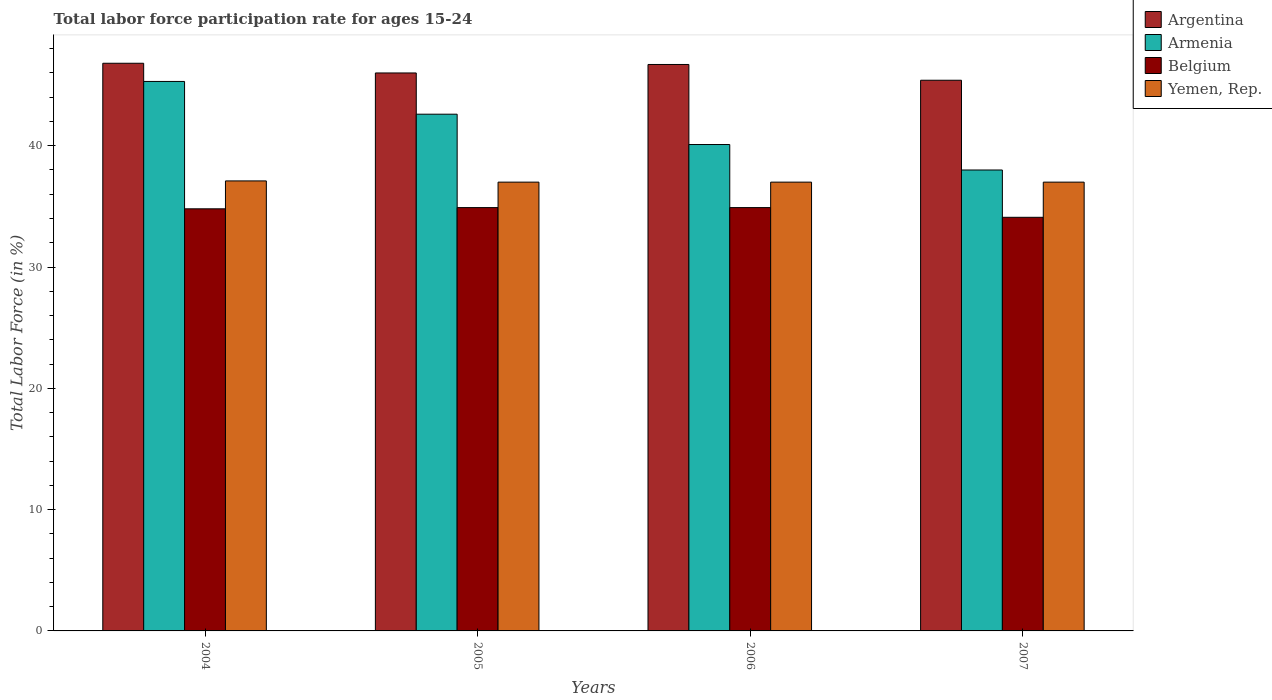How many groups of bars are there?
Your answer should be compact. 4. Are the number of bars per tick equal to the number of legend labels?
Provide a short and direct response. Yes. Are the number of bars on each tick of the X-axis equal?
Offer a terse response. Yes. How many bars are there on the 3rd tick from the right?
Provide a succinct answer. 4. What is the labor force participation rate in Argentina in 2007?
Offer a terse response. 45.4. Across all years, what is the maximum labor force participation rate in Belgium?
Provide a short and direct response. 34.9. Across all years, what is the minimum labor force participation rate in Argentina?
Provide a succinct answer. 45.4. In which year was the labor force participation rate in Armenia maximum?
Make the answer very short. 2004. In which year was the labor force participation rate in Belgium minimum?
Provide a short and direct response. 2007. What is the total labor force participation rate in Argentina in the graph?
Keep it short and to the point. 184.9. What is the difference between the labor force participation rate in Armenia in 2006 and that in 2007?
Provide a succinct answer. 2.1. What is the difference between the labor force participation rate in Belgium in 2005 and the labor force participation rate in Argentina in 2006?
Your response must be concise. -11.8. What is the average labor force participation rate in Yemen, Rep. per year?
Your response must be concise. 37.02. What is the ratio of the labor force participation rate in Yemen, Rep. in 2004 to that in 2005?
Provide a succinct answer. 1. Is the labor force participation rate in Belgium in 2004 less than that in 2006?
Your response must be concise. Yes. What is the difference between the highest and the second highest labor force participation rate in Armenia?
Offer a very short reply. 2.7. What is the difference between the highest and the lowest labor force participation rate in Belgium?
Offer a terse response. 0.8. In how many years, is the labor force participation rate in Yemen, Rep. greater than the average labor force participation rate in Yemen, Rep. taken over all years?
Provide a succinct answer. 1. Is it the case that in every year, the sum of the labor force participation rate in Argentina and labor force participation rate in Armenia is greater than the sum of labor force participation rate in Belgium and labor force participation rate in Yemen, Rep.?
Give a very brief answer. Yes. What does the 2nd bar from the left in 2004 represents?
Your answer should be very brief. Armenia. What does the 3rd bar from the right in 2006 represents?
Provide a short and direct response. Armenia. How many bars are there?
Ensure brevity in your answer.  16. What is the difference between two consecutive major ticks on the Y-axis?
Your response must be concise. 10. Are the values on the major ticks of Y-axis written in scientific E-notation?
Provide a short and direct response. No. Does the graph contain any zero values?
Ensure brevity in your answer.  No. Does the graph contain grids?
Your response must be concise. No. Where does the legend appear in the graph?
Ensure brevity in your answer.  Top right. How many legend labels are there?
Provide a succinct answer. 4. How are the legend labels stacked?
Provide a short and direct response. Vertical. What is the title of the graph?
Provide a succinct answer. Total labor force participation rate for ages 15-24. What is the label or title of the Y-axis?
Keep it short and to the point. Total Labor Force (in %). What is the Total Labor Force (in %) in Argentina in 2004?
Offer a terse response. 46.8. What is the Total Labor Force (in %) in Armenia in 2004?
Offer a terse response. 45.3. What is the Total Labor Force (in %) in Belgium in 2004?
Ensure brevity in your answer.  34.8. What is the Total Labor Force (in %) in Yemen, Rep. in 2004?
Your answer should be very brief. 37.1. What is the Total Labor Force (in %) of Argentina in 2005?
Give a very brief answer. 46. What is the Total Labor Force (in %) in Armenia in 2005?
Your answer should be compact. 42.6. What is the Total Labor Force (in %) of Belgium in 2005?
Ensure brevity in your answer.  34.9. What is the Total Labor Force (in %) in Yemen, Rep. in 2005?
Provide a succinct answer. 37. What is the Total Labor Force (in %) of Argentina in 2006?
Your answer should be very brief. 46.7. What is the Total Labor Force (in %) of Armenia in 2006?
Ensure brevity in your answer.  40.1. What is the Total Labor Force (in %) of Belgium in 2006?
Offer a very short reply. 34.9. What is the Total Labor Force (in %) of Yemen, Rep. in 2006?
Offer a terse response. 37. What is the Total Labor Force (in %) of Argentina in 2007?
Offer a very short reply. 45.4. What is the Total Labor Force (in %) of Belgium in 2007?
Offer a terse response. 34.1. What is the Total Labor Force (in %) in Yemen, Rep. in 2007?
Your answer should be compact. 37. Across all years, what is the maximum Total Labor Force (in %) in Argentina?
Ensure brevity in your answer.  46.8. Across all years, what is the maximum Total Labor Force (in %) in Armenia?
Your response must be concise. 45.3. Across all years, what is the maximum Total Labor Force (in %) in Belgium?
Provide a short and direct response. 34.9. Across all years, what is the maximum Total Labor Force (in %) of Yemen, Rep.?
Provide a succinct answer. 37.1. Across all years, what is the minimum Total Labor Force (in %) of Argentina?
Ensure brevity in your answer.  45.4. Across all years, what is the minimum Total Labor Force (in %) in Belgium?
Offer a terse response. 34.1. What is the total Total Labor Force (in %) in Argentina in the graph?
Your answer should be very brief. 184.9. What is the total Total Labor Force (in %) of Armenia in the graph?
Your answer should be compact. 166. What is the total Total Labor Force (in %) of Belgium in the graph?
Provide a succinct answer. 138.7. What is the total Total Labor Force (in %) in Yemen, Rep. in the graph?
Provide a short and direct response. 148.1. What is the difference between the Total Labor Force (in %) in Argentina in 2004 and that in 2005?
Provide a short and direct response. 0.8. What is the difference between the Total Labor Force (in %) in Armenia in 2004 and that in 2005?
Keep it short and to the point. 2.7. What is the difference between the Total Labor Force (in %) in Belgium in 2004 and that in 2005?
Keep it short and to the point. -0.1. What is the difference between the Total Labor Force (in %) in Argentina in 2004 and that in 2006?
Offer a terse response. 0.1. What is the difference between the Total Labor Force (in %) in Yemen, Rep. in 2004 and that in 2006?
Provide a succinct answer. 0.1. What is the difference between the Total Labor Force (in %) of Argentina in 2004 and that in 2007?
Provide a succinct answer. 1.4. What is the difference between the Total Labor Force (in %) in Armenia in 2004 and that in 2007?
Offer a terse response. 7.3. What is the difference between the Total Labor Force (in %) of Armenia in 2005 and that in 2006?
Offer a very short reply. 2.5. What is the difference between the Total Labor Force (in %) in Armenia in 2005 and that in 2007?
Ensure brevity in your answer.  4.6. What is the difference between the Total Labor Force (in %) of Belgium in 2005 and that in 2007?
Make the answer very short. 0.8. What is the difference between the Total Labor Force (in %) of Yemen, Rep. in 2005 and that in 2007?
Your response must be concise. 0. What is the difference between the Total Labor Force (in %) of Argentina in 2006 and that in 2007?
Offer a very short reply. 1.3. What is the difference between the Total Labor Force (in %) of Armenia in 2006 and that in 2007?
Your answer should be compact. 2.1. What is the difference between the Total Labor Force (in %) of Belgium in 2006 and that in 2007?
Provide a succinct answer. 0.8. What is the difference between the Total Labor Force (in %) in Armenia in 2004 and the Total Labor Force (in %) in Belgium in 2005?
Your response must be concise. 10.4. What is the difference between the Total Labor Force (in %) in Armenia in 2004 and the Total Labor Force (in %) in Yemen, Rep. in 2005?
Keep it short and to the point. 8.3. What is the difference between the Total Labor Force (in %) in Belgium in 2004 and the Total Labor Force (in %) in Yemen, Rep. in 2005?
Your answer should be compact. -2.2. What is the difference between the Total Labor Force (in %) in Argentina in 2004 and the Total Labor Force (in %) in Armenia in 2006?
Your response must be concise. 6.7. What is the difference between the Total Labor Force (in %) of Argentina in 2004 and the Total Labor Force (in %) of Armenia in 2007?
Give a very brief answer. 8.8. What is the difference between the Total Labor Force (in %) in Argentina in 2004 and the Total Labor Force (in %) in Belgium in 2007?
Provide a succinct answer. 12.7. What is the difference between the Total Labor Force (in %) in Argentina in 2004 and the Total Labor Force (in %) in Yemen, Rep. in 2007?
Your answer should be compact. 9.8. What is the difference between the Total Labor Force (in %) of Armenia in 2004 and the Total Labor Force (in %) of Belgium in 2007?
Your answer should be compact. 11.2. What is the difference between the Total Labor Force (in %) in Armenia in 2004 and the Total Labor Force (in %) in Yemen, Rep. in 2007?
Keep it short and to the point. 8.3. What is the difference between the Total Labor Force (in %) in Belgium in 2004 and the Total Labor Force (in %) in Yemen, Rep. in 2007?
Your answer should be very brief. -2.2. What is the difference between the Total Labor Force (in %) in Argentina in 2005 and the Total Labor Force (in %) in Armenia in 2006?
Offer a very short reply. 5.9. What is the difference between the Total Labor Force (in %) in Argentina in 2005 and the Total Labor Force (in %) in Belgium in 2006?
Make the answer very short. 11.1. What is the difference between the Total Labor Force (in %) in Armenia in 2005 and the Total Labor Force (in %) in Belgium in 2006?
Your answer should be very brief. 7.7. What is the difference between the Total Labor Force (in %) in Argentina in 2005 and the Total Labor Force (in %) in Belgium in 2007?
Offer a very short reply. 11.9. What is the difference between the Total Labor Force (in %) in Armenia in 2005 and the Total Labor Force (in %) in Belgium in 2007?
Ensure brevity in your answer.  8.5. What is the difference between the Total Labor Force (in %) of Belgium in 2005 and the Total Labor Force (in %) of Yemen, Rep. in 2007?
Give a very brief answer. -2.1. What is the difference between the Total Labor Force (in %) of Argentina in 2006 and the Total Labor Force (in %) of Belgium in 2007?
Your answer should be compact. 12.6. What is the difference between the Total Labor Force (in %) of Argentina in 2006 and the Total Labor Force (in %) of Yemen, Rep. in 2007?
Provide a succinct answer. 9.7. What is the difference between the Total Labor Force (in %) of Armenia in 2006 and the Total Labor Force (in %) of Yemen, Rep. in 2007?
Offer a terse response. 3.1. What is the difference between the Total Labor Force (in %) of Belgium in 2006 and the Total Labor Force (in %) of Yemen, Rep. in 2007?
Provide a short and direct response. -2.1. What is the average Total Labor Force (in %) in Argentina per year?
Ensure brevity in your answer.  46.23. What is the average Total Labor Force (in %) of Armenia per year?
Your answer should be very brief. 41.5. What is the average Total Labor Force (in %) of Belgium per year?
Ensure brevity in your answer.  34.67. What is the average Total Labor Force (in %) in Yemen, Rep. per year?
Your answer should be very brief. 37.02. In the year 2004, what is the difference between the Total Labor Force (in %) of Armenia and Total Labor Force (in %) of Yemen, Rep.?
Give a very brief answer. 8.2. In the year 2005, what is the difference between the Total Labor Force (in %) in Argentina and Total Labor Force (in %) in Belgium?
Ensure brevity in your answer.  11.1. In the year 2005, what is the difference between the Total Labor Force (in %) of Armenia and Total Labor Force (in %) of Belgium?
Offer a terse response. 7.7. In the year 2005, what is the difference between the Total Labor Force (in %) of Belgium and Total Labor Force (in %) of Yemen, Rep.?
Offer a terse response. -2.1. In the year 2006, what is the difference between the Total Labor Force (in %) of Argentina and Total Labor Force (in %) of Armenia?
Make the answer very short. 6.6. In the year 2006, what is the difference between the Total Labor Force (in %) of Argentina and Total Labor Force (in %) of Yemen, Rep.?
Give a very brief answer. 9.7. In the year 2006, what is the difference between the Total Labor Force (in %) in Belgium and Total Labor Force (in %) in Yemen, Rep.?
Offer a very short reply. -2.1. In the year 2007, what is the difference between the Total Labor Force (in %) of Argentina and Total Labor Force (in %) of Belgium?
Your answer should be compact. 11.3. In the year 2007, what is the difference between the Total Labor Force (in %) in Argentina and Total Labor Force (in %) in Yemen, Rep.?
Provide a short and direct response. 8.4. In the year 2007, what is the difference between the Total Labor Force (in %) of Armenia and Total Labor Force (in %) of Belgium?
Offer a terse response. 3.9. In the year 2007, what is the difference between the Total Labor Force (in %) of Armenia and Total Labor Force (in %) of Yemen, Rep.?
Your response must be concise. 1. In the year 2007, what is the difference between the Total Labor Force (in %) in Belgium and Total Labor Force (in %) in Yemen, Rep.?
Give a very brief answer. -2.9. What is the ratio of the Total Labor Force (in %) in Argentina in 2004 to that in 2005?
Your answer should be very brief. 1.02. What is the ratio of the Total Labor Force (in %) in Armenia in 2004 to that in 2005?
Provide a short and direct response. 1.06. What is the ratio of the Total Labor Force (in %) of Yemen, Rep. in 2004 to that in 2005?
Your answer should be very brief. 1. What is the ratio of the Total Labor Force (in %) of Armenia in 2004 to that in 2006?
Provide a succinct answer. 1.13. What is the ratio of the Total Labor Force (in %) in Belgium in 2004 to that in 2006?
Offer a terse response. 1. What is the ratio of the Total Labor Force (in %) of Yemen, Rep. in 2004 to that in 2006?
Make the answer very short. 1. What is the ratio of the Total Labor Force (in %) of Argentina in 2004 to that in 2007?
Your response must be concise. 1.03. What is the ratio of the Total Labor Force (in %) in Armenia in 2004 to that in 2007?
Give a very brief answer. 1.19. What is the ratio of the Total Labor Force (in %) of Belgium in 2004 to that in 2007?
Provide a succinct answer. 1.02. What is the ratio of the Total Labor Force (in %) in Armenia in 2005 to that in 2006?
Keep it short and to the point. 1.06. What is the ratio of the Total Labor Force (in %) of Argentina in 2005 to that in 2007?
Your answer should be compact. 1.01. What is the ratio of the Total Labor Force (in %) in Armenia in 2005 to that in 2007?
Provide a short and direct response. 1.12. What is the ratio of the Total Labor Force (in %) of Belgium in 2005 to that in 2007?
Provide a short and direct response. 1.02. What is the ratio of the Total Labor Force (in %) in Argentina in 2006 to that in 2007?
Provide a succinct answer. 1.03. What is the ratio of the Total Labor Force (in %) in Armenia in 2006 to that in 2007?
Your response must be concise. 1.06. What is the ratio of the Total Labor Force (in %) in Belgium in 2006 to that in 2007?
Ensure brevity in your answer.  1.02. What is the ratio of the Total Labor Force (in %) in Yemen, Rep. in 2006 to that in 2007?
Give a very brief answer. 1. What is the difference between the highest and the second highest Total Labor Force (in %) in Argentina?
Give a very brief answer. 0.1. What is the difference between the highest and the lowest Total Labor Force (in %) of Yemen, Rep.?
Your response must be concise. 0.1. 